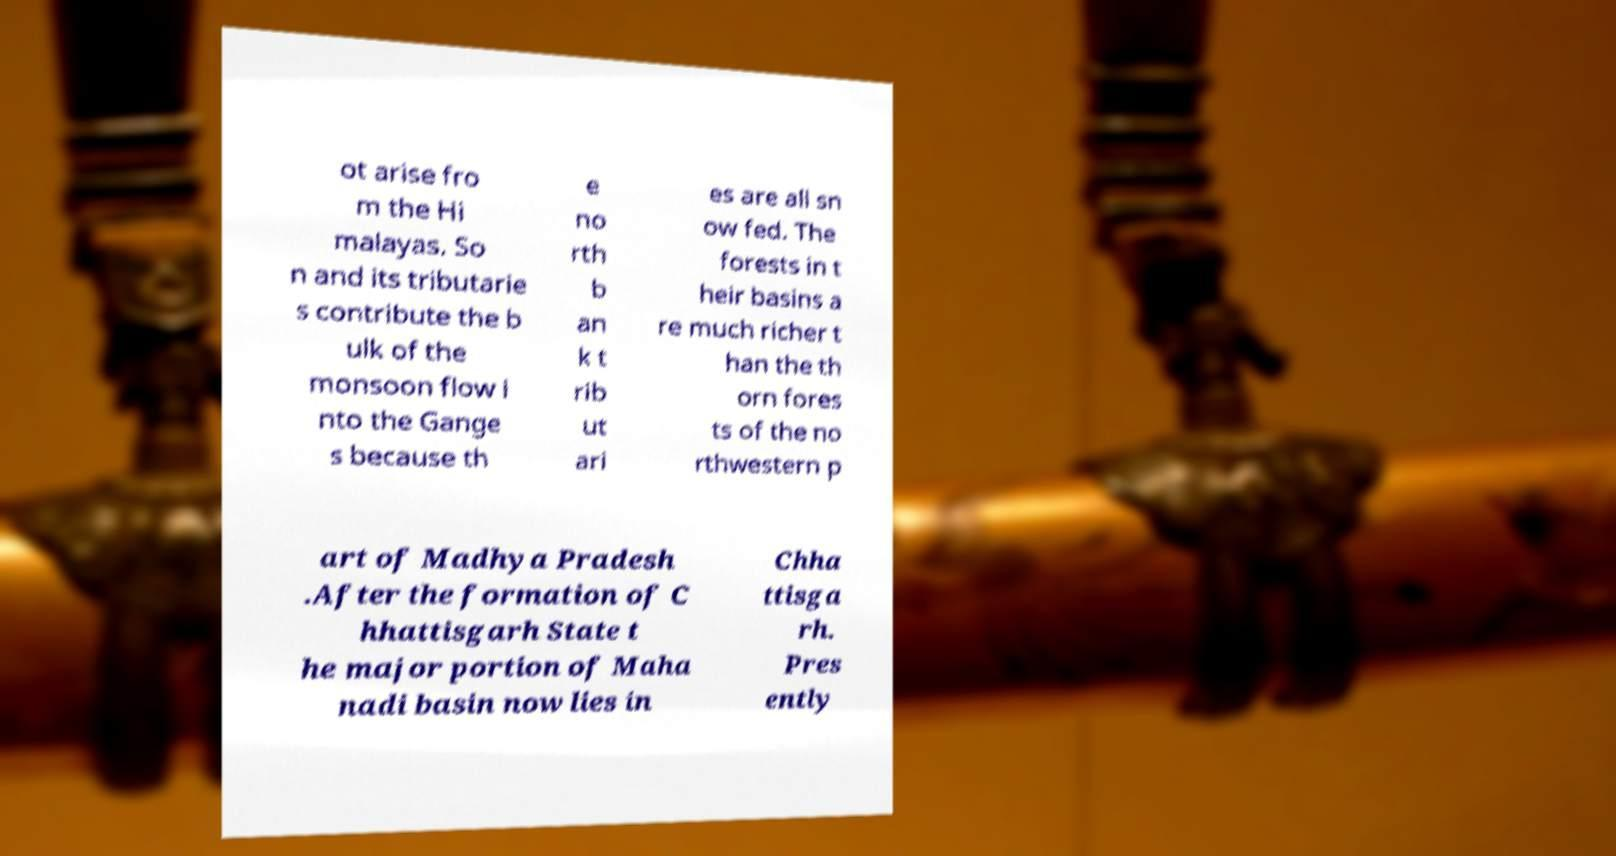What messages or text are displayed in this image? I need them in a readable, typed format. ot arise fro m the Hi malayas. So n and its tributarie s contribute the b ulk of the monsoon flow i nto the Gange s because th e no rth b an k t rib ut ari es are all sn ow fed. The forests in t heir basins a re much richer t han the th orn fores ts of the no rthwestern p art of Madhya Pradesh .After the formation of C hhattisgarh State t he major portion of Maha nadi basin now lies in Chha ttisga rh. Pres ently 